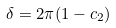<formula> <loc_0><loc_0><loc_500><loc_500>\delta = 2 \pi ( 1 - c _ { 2 } )</formula> 